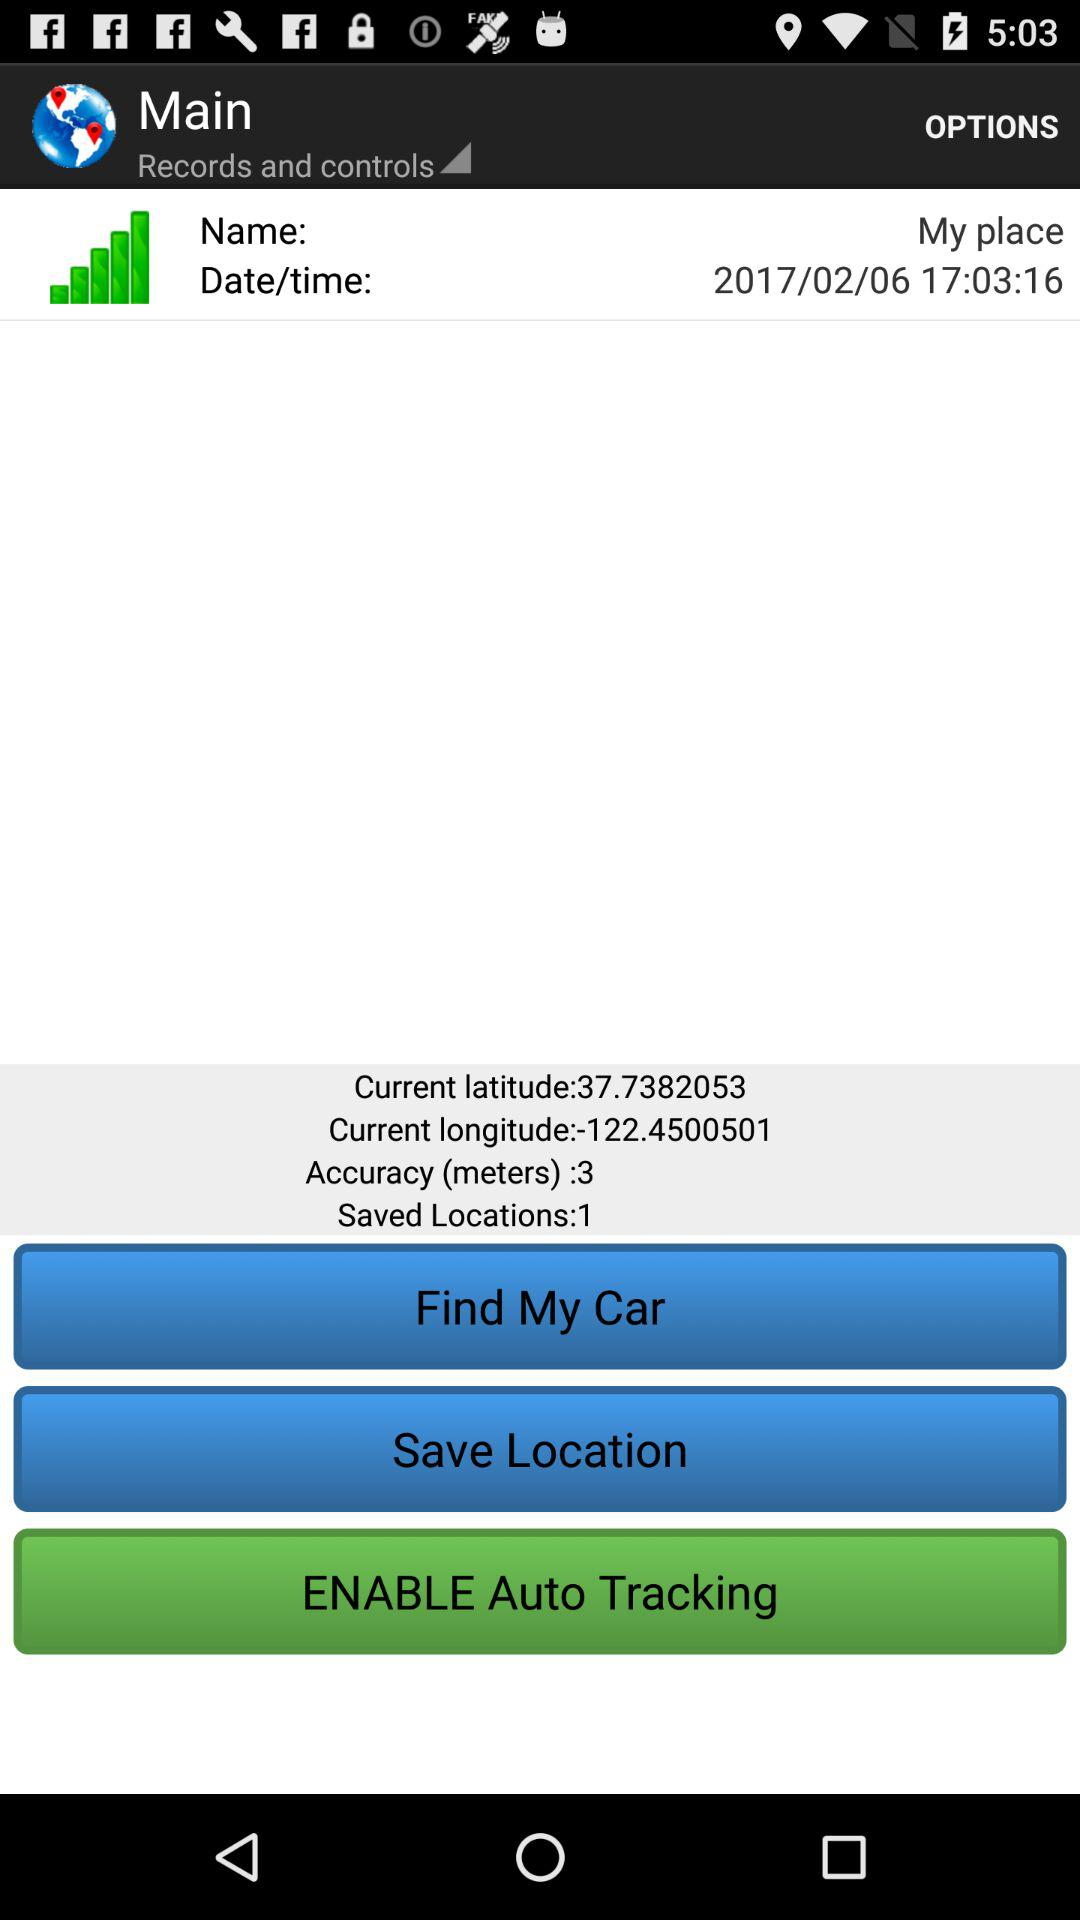What is the given name? The given name is My place. 